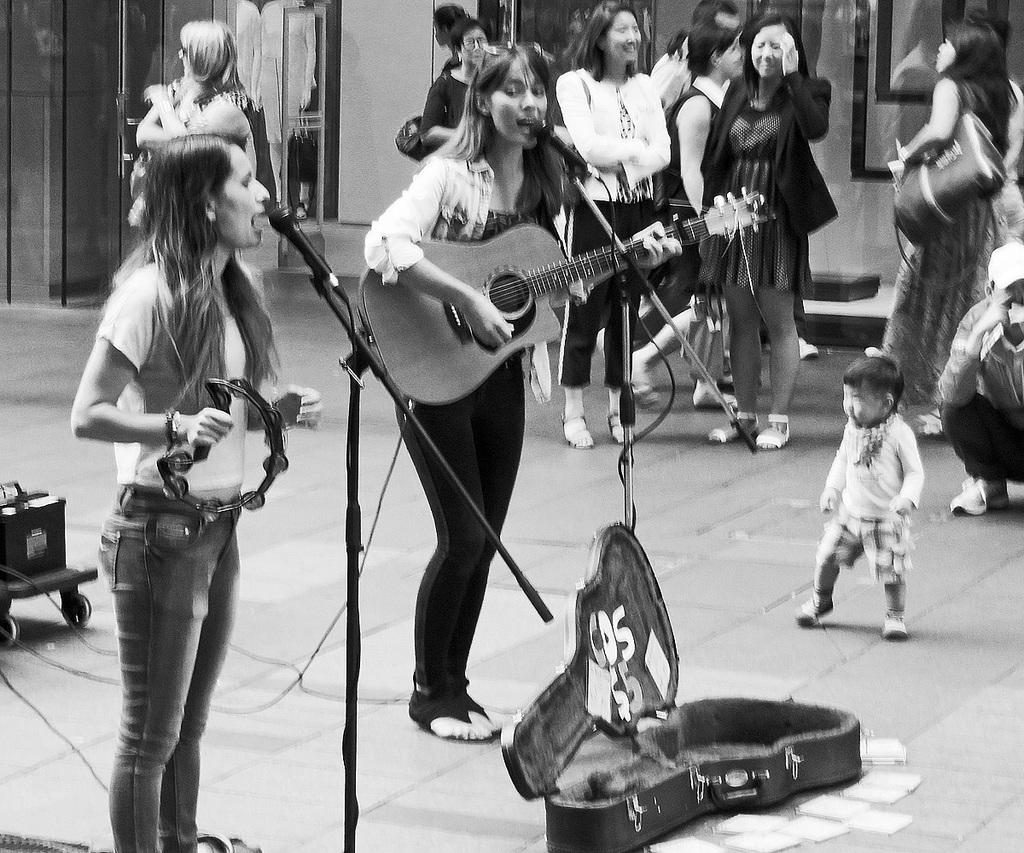How many people are performing in the image? There are two girls in the image who are giving a musical performance. What is happening in the background of the image? There are people moving in the background of the image. What is the color scheme of the image? The image is black and white. What type of distribution system is being used by the son of the farmer in the image? There is no son or farmer present in the image, and therefore no distribution system can be observed. 